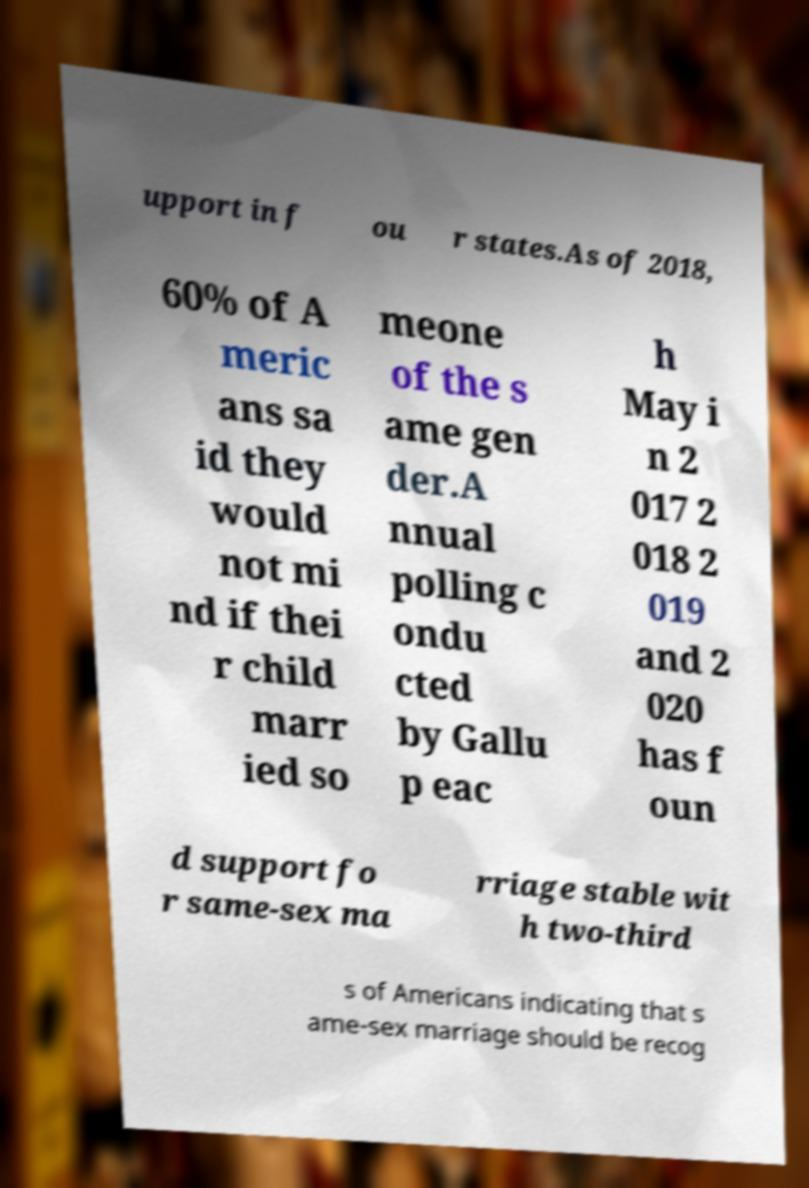There's text embedded in this image that I need extracted. Can you transcribe it verbatim? upport in f ou r states.As of 2018, 60% of A meric ans sa id they would not mi nd if thei r child marr ied so meone of the s ame gen der.A nnual polling c ondu cted by Gallu p eac h May i n 2 017 2 018 2 019 and 2 020 has f oun d support fo r same-sex ma rriage stable wit h two-third s of Americans indicating that s ame-sex marriage should be recog 